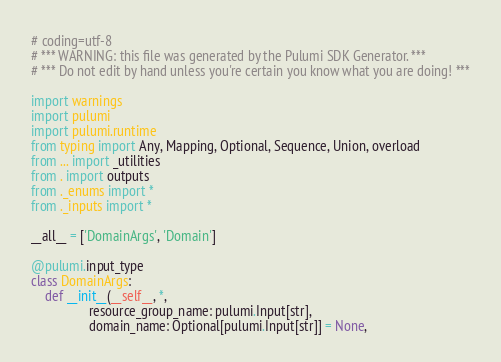Convert code to text. <code><loc_0><loc_0><loc_500><loc_500><_Python_># coding=utf-8
# *** WARNING: this file was generated by the Pulumi SDK Generator. ***
# *** Do not edit by hand unless you're certain you know what you are doing! ***

import warnings
import pulumi
import pulumi.runtime
from typing import Any, Mapping, Optional, Sequence, Union, overload
from ... import _utilities
from . import outputs
from ._enums import *
from ._inputs import *

__all__ = ['DomainArgs', 'Domain']

@pulumi.input_type
class DomainArgs:
    def __init__(__self__, *,
                 resource_group_name: pulumi.Input[str],
                 domain_name: Optional[pulumi.Input[str]] = None,</code> 